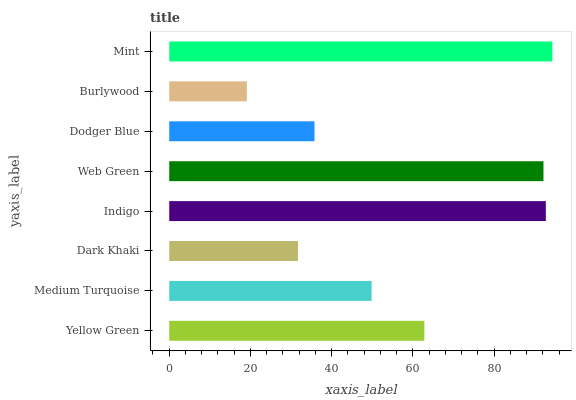Is Burlywood the minimum?
Answer yes or no. Yes. Is Mint the maximum?
Answer yes or no. Yes. Is Medium Turquoise the minimum?
Answer yes or no. No. Is Medium Turquoise the maximum?
Answer yes or no. No. Is Yellow Green greater than Medium Turquoise?
Answer yes or no. Yes. Is Medium Turquoise less than Yellow Green?
Answer yes or no. Yes. Is Medium Turquoise greater than Yellow Green?
Answer yes or no. No. Is Yellow Green less than Medium Turquoise?
Answer yes or no. No. Is Yellow Green the high median?
Answer yes or no. Yes. Is Medium Turquoise the low median?
Answer yes or no. Yes. Is Dark Khaki the high median?
Answer yes or no. No. Is Dark Khaki the low median?
Answer yes or no. No. 